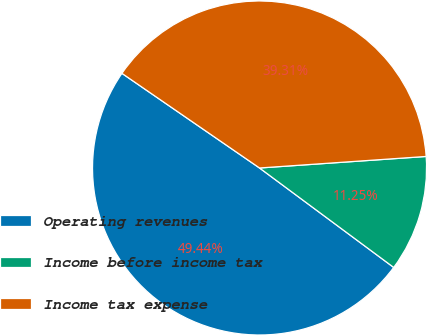Convert chart. <chart><loc_0><loc_0><loc_500><loc_500><pie_chart><fcel>Operating revenues<fcel>Income before income tax<fcel>Income tax expense<nl><fcel>49.44%<fcel>11.25%<fcel>39.31%<nl></chart> 